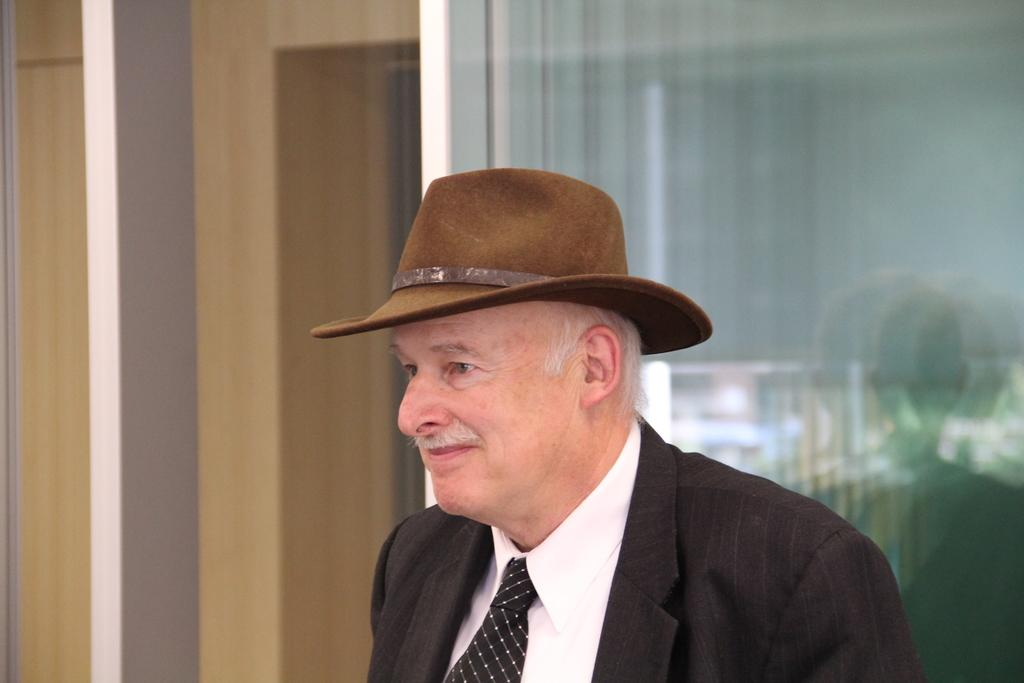Who is present in the image? There is a man in the image. What is the man wearing? The man is wearing a suit and a tie. What is on the man's head? There is a cap on the man's head. What can be seen in the background of the image? There is a glass window in the background of the image. What type of lettuce is visible on the man's tie in the image? There is no lettuce visible on the man's tie in the image. How much money is the man holding in the image? The man is not holding any money in the image. 